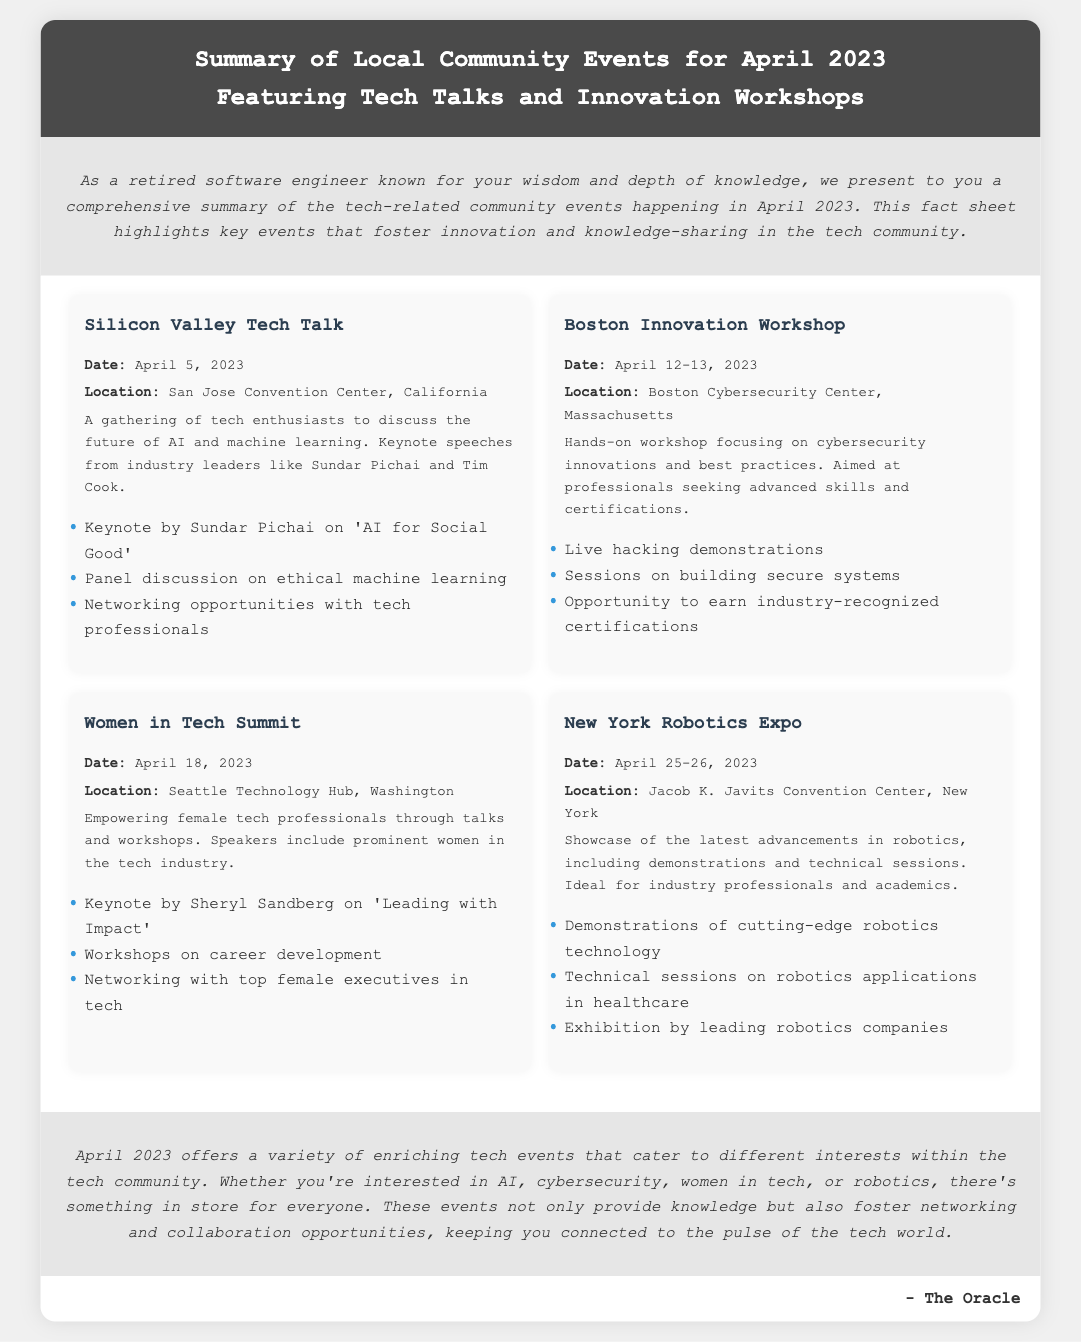What is the date of the Silicon Valley Tech Talk? The document states that the event takes place on April 5, 2023.
Answer: April 5, 2023 Who is the keynote speaker at the Women in Tech Summit? The document lists Sheryl Sandberg as the keynote speaker for this event.
Answer: Sheryl Sandberg How many days will the Boston Innovation Workshop run? The document mentions that the workshop is scheduled for April 12-13, 2023, indicating it runs for 2 days.
Answer: 2 days What is one highlight of the New York Robotics Expo? The document lists a highlight as the demonstrations of cutting-edge robotics technology.
Answer: Demonstrations of cutting-edge robotics technology Which city will host the Women in Tech Summit? The document specifies Seattle as the location for this summit.
Answer: Seattle What is the main focus of the Boston Innovation Workshop? The document describes the workshop as focusing on cybersecurity innovations and best practices.
Answer: Cybersecurity innovations and best practices How many events are summarized in the document? The document summarizes four tech-related community events for April 2023.
Answer: Four events What is the key theme discussed at the Silicon Valley Tech Talk? The document mentions that the theme is about the future of AI and machine learning.
Answer: The future of AI and machine learning What type of document is this fact sheet? The nature of the document is described as a summary of local community tech events for a specific month.
Answer: Fact sheet 